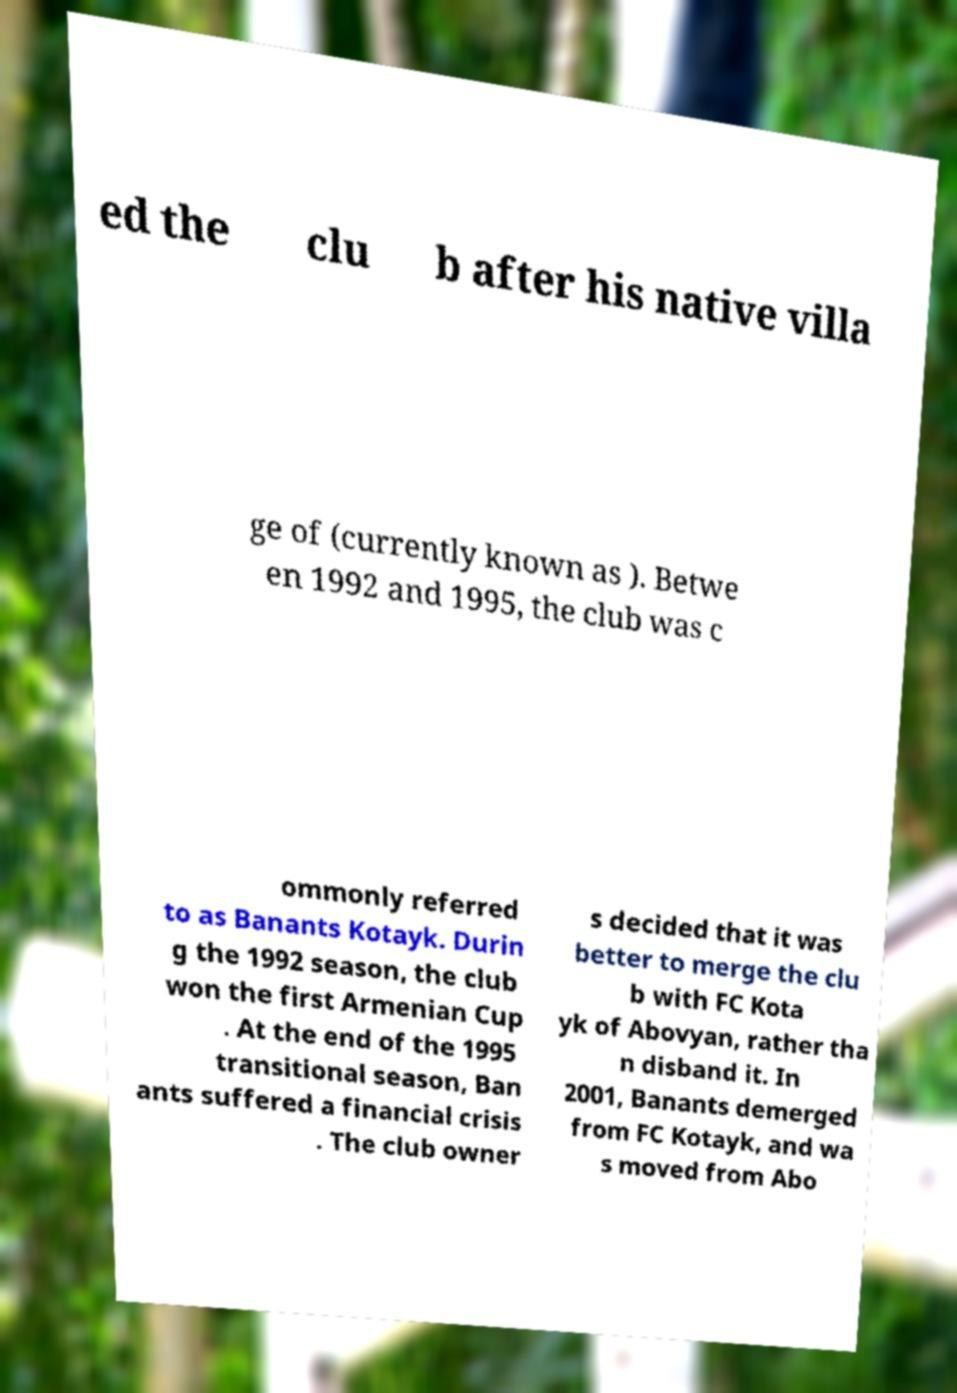Can you read and provide the text displayed in the image?This photo seems to have some interesting text. Can you extract and type it out for me? ed the clu b after his native villa ge of (currently known as ). Betwe en 1992 and 1995, the club was c ommonly referred to as Banants Kotayk. Durin g the 1992 season, the club won the first Armenian Cup . At the end of the 1995 transitional season, Ban ants suffered a financial crisis . The club owner s decided that it was better to merge the clu b with FC Kota yk of Abovyan, rather tha n disband it. In 2001, Banants demerged from FC Kotayk, and wa s moved from Abo 